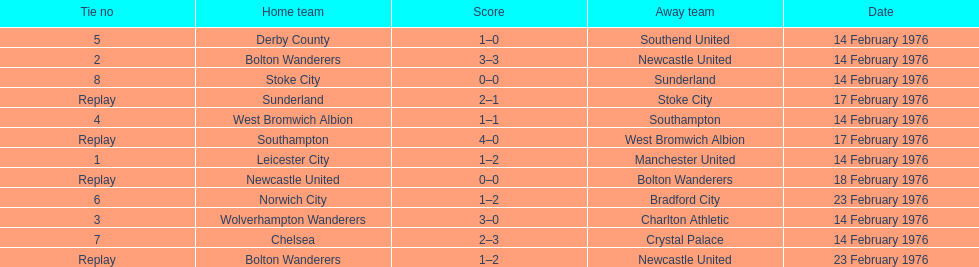How many of these games occurred before 17 february 1976? 7. 